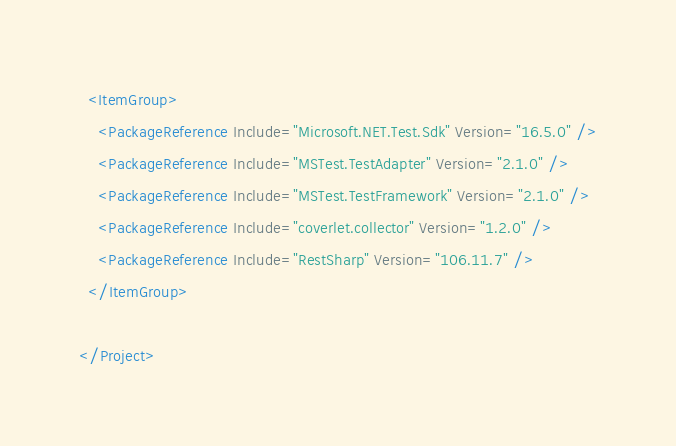Convert code to text. <code><loc_0><loc_0><loc_500><loc_500><_XML_>
  <ItemGroup>
    <PackageReference Include="Microsoft.NET.Test.Sdk" Version="16.5.0" />
    <PackageReference Include="MSTest.TestAdapter" Version="2.1.0" />
    <PackageReference Include="MSTest.TestFramework" Version="2.1.0" />
    <PackageReference Include="coverlet.collector" Version="1.2.0" />
    <PackageReference Include="RestSharp" Version="106.11.7" />
  </ItemGroup>

</Project>
</code> 